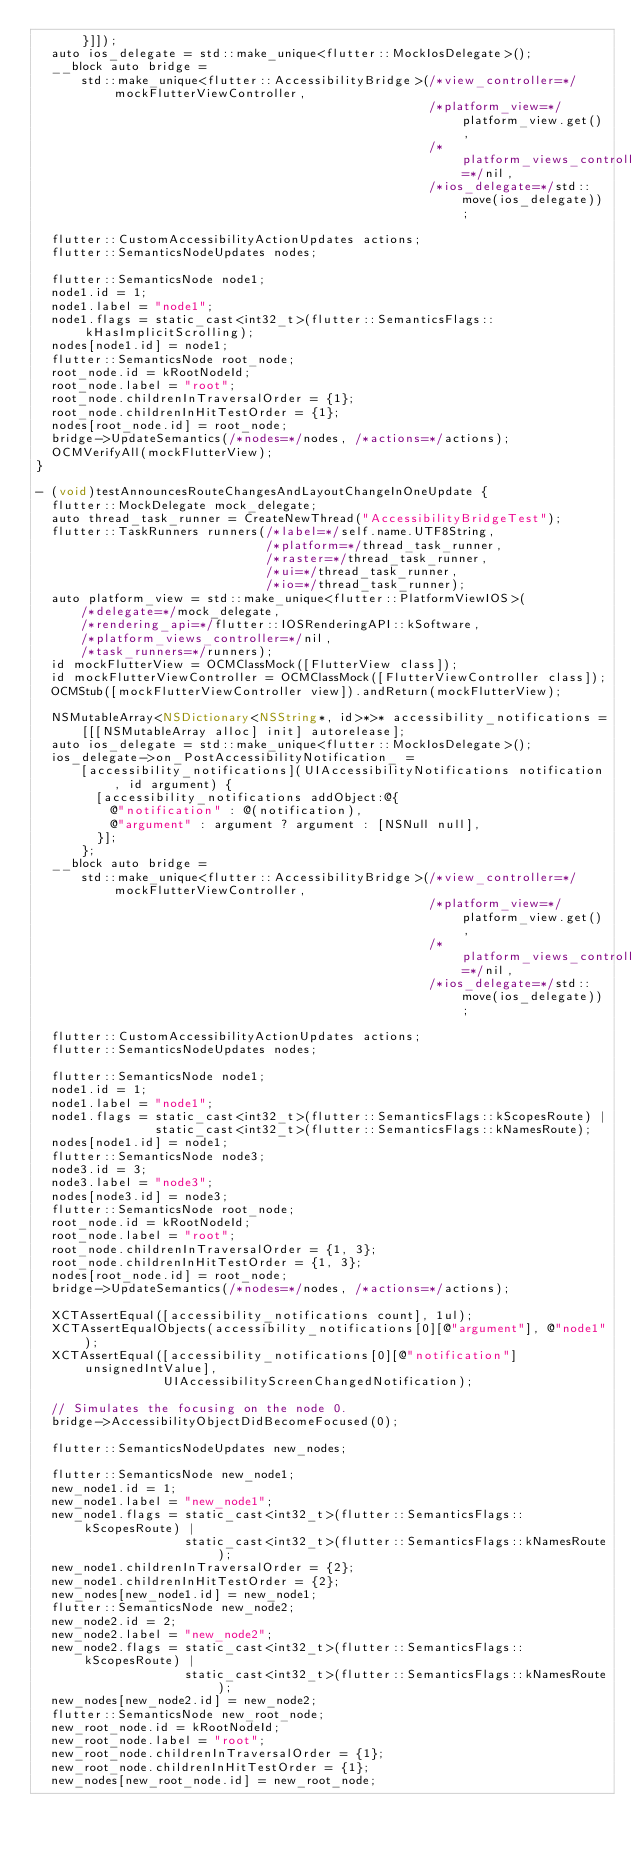Convert code to text. <code><loc_0><loc_0><loc_500><loc_500><_ObjectiveC_>      }]]);
  auto ios_delegate = std::make_unique<flutter::MockIosDelegate>();
  __block auto bridge =
      std::make_unique<flutter::AccessibilityBridge>(/*view_controller=*/mockFlutterViewController,
                                                     /*platform_view=*/platform_view.get(),
                                                     /*platform_views_controller=*/nil,
                                                     /*ios_delegate=*/std::move(ios_delegate));

  flutter::CustomAccessibilityActionUpdates actions;
  flutter::SemanticsNodeUpdates nodes;

  flutter::SemanticsNode node1;
  node1.id = 1;
  node1.label = "node1";
  node1.flags = static_cast<int32_t>(flutter::SemanticsFlags::kHasImplicitScrolling);
  nodes[node1.id] = node1;
  flutter::SemanticsNode root_node;
  root_node.id = kRootNodeId;
  root_node.label = "root";
  root_node.childrenInTraversalOrder = {1};
  root_node.childrenInHitTestOrder = {1};
  nodes[root_node.id] = root_node;
  bridge->UpdateSemantics(/*nodes=*/nodes, /*actions=*/actions);
  OCMVerifyAll(mockFlutterView);
}

- (void)testAnnouncesRouteChangesAndLayoutChangeInOneUpdate {
  flutter::MockDelegate mock_delegate;
  auto thread_task_runner = CreateNewThread("AccessibilityBridgeTest");
  flutter::TaskRunners runners(/*label=*/self.name.UTF8String,
                               /*platform=*/thread_task_runner,
                               /*raster=*/thread_task_runner,
                               /*ui=*/thread_task_runner,
                               /*io=*/thread_task_runner);
  auto platform_view = std::make_unique<flutter::PlatformViewIOS>(
      /*delegate=*/mock_delegate,
      /*rendering_api=*/flutter::IOSRenderingAPI::kSoftware,
      /*platform_views_controller=*/nil,
      /*task_runners=*/runners);
  id mockFlutterView = OCMClassMock([FlutterView class]);
  id mockFlutterViewController = OCMClassMock([FlutterViewController class]);
  OCMStub([mockFlutterViewController view]).andReturn(mockFlutterView);

  NSMutableArray<NSDictionary<NSString*, id>*>* accessibility_notifications =
      [[[NSMutableArray alloc] init] autorelease];
  auto ios_delegate = std::make_unique<flutter::MockIosDelegate>();
  ios_delegate->on_PostAccessibilityNotification_ =
      [accessibility_notifications](UIAccessibilityNotifications notification, id argument) {
        [accessibility_notifications addObject:@{
          @"notification" : @(notification),
          @"argument" : argument ? argument : [NSNull null],
        }];
      };
  __block auto bridge =
      std::make_unique<flutter::AccessibilityBridge>(/*view_controller=*/mockFlutterViewController,
                                                     /*platform_view=*/platform_view.get(),
                                                     /*platform_views_controller=*/nil,
                                                     /*ios_delegate=*/std::move(ios_delegate));

  flutter::CustomAccessibilityActionUpdates actions;
  flutter::SemanticsNodeUpdates nodes;

  flutter::SemanticsNode node1;
  node1.id = 1;
  node1.label = "node1";
  node1.flags = static_cast<int32_t>(flutter::SemanticsFlags::kScopesRoute) |
                static_cast<int32_t>(flutter::SemanticsFlags::kNamesRoute);
  nodes[node1.id] = node1;
  flutter::SemanticsNode node3;
  node3.id = 3;
  node3.label = "node3";
  nodes[node3.id] = node3;
  flutter::SemanticsNode root_node;
  root_node.id = kRootNodeId;
  root_node.label = "root";
  root_node.childrenInTraversalOrder = {1, 3};
  root_node.childrenInHitTestOrder = {1, 3};
  nodes[root_node.id] = root_node;
  bridge->UpdateSemantics(/*nodes=*/nodes, /*actions=*/actions);

  XCTAssertEqual([accessibility_notifications count], 1ul);
  XCTAssertEqualObjects(accessibility_notifications[0][@"argument"], @"node1");
  XCTAssertEqual([accessibility_notifications[0][@"notification"] unsignedIntValue],
                 UIAccessibilityScreenChangedNotification);

  // Simulates the focusing on the node 0.
  bridge->AccessibilityObjectDidBecomeFocused(0);

  flutter::SemanticsNodeUpdates new_nodes;

  flutter::SemanticsNode new_node1;
  new_node1.id = 1;
  new_node1.label = "new_node1";
  new_node1.flags = static_cast<int32_t>(flutter::SemanticsFlags::kScopesRoute) |
                    static_cast<int32_t>(flutter::SemanticsFlags::kNamesRoute);
  new_node1.childrenInTraversalOrder = {2};
  new_node1.childrenInHitTestOrder = {2};
  new_nodes[new_node1.id] = new_node1;
  flutter::SemanticsNode new_node2;
  new_node2.id = 2;
  new_node2.label = "new_node2";
  new_node2.flags = static_cast<int32_t>(flutter::SemanticsFlags::kScopesRoute) |
                    static_cast<int32_t>(flutter::SemanticsFlags::kNamesRoute);
  new_nodes[new_node2.id] = new_node2;
  flutter::SemanticsNode new_root_node;
  new_root_node.id = kRootNodeId;
  new_root_node.label = "root";
  new_root_node.childrenInTraversalOrder = {1};
  new_root_node.childrenInHitTestOrder = {1};
  new_nodes[new_root_node.id] = new_root_node;</code> 